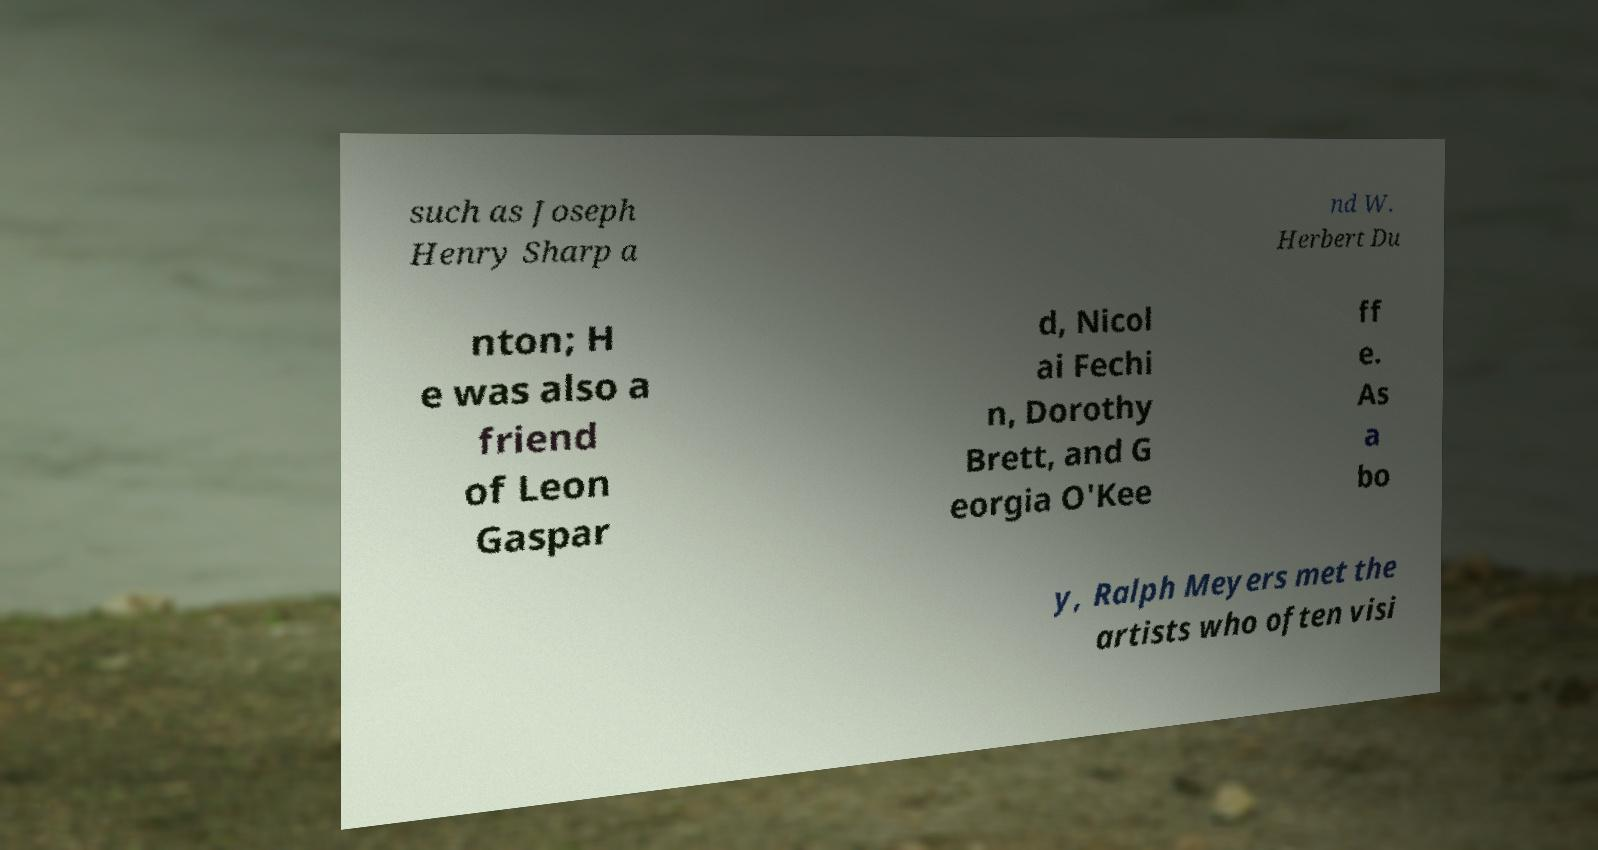Could you assist in decoding the text presented in this image and type it out clearly? such as Joseph Henry Sharp a nd W. Herbert Du nton; H e was also a friend of Leon Gaspar d, Nicol ai Fechi n, Dorothy Brett, and G eorgia O'Kee ff e. As a bo y, Ralph Meyers met the artists who often visi 